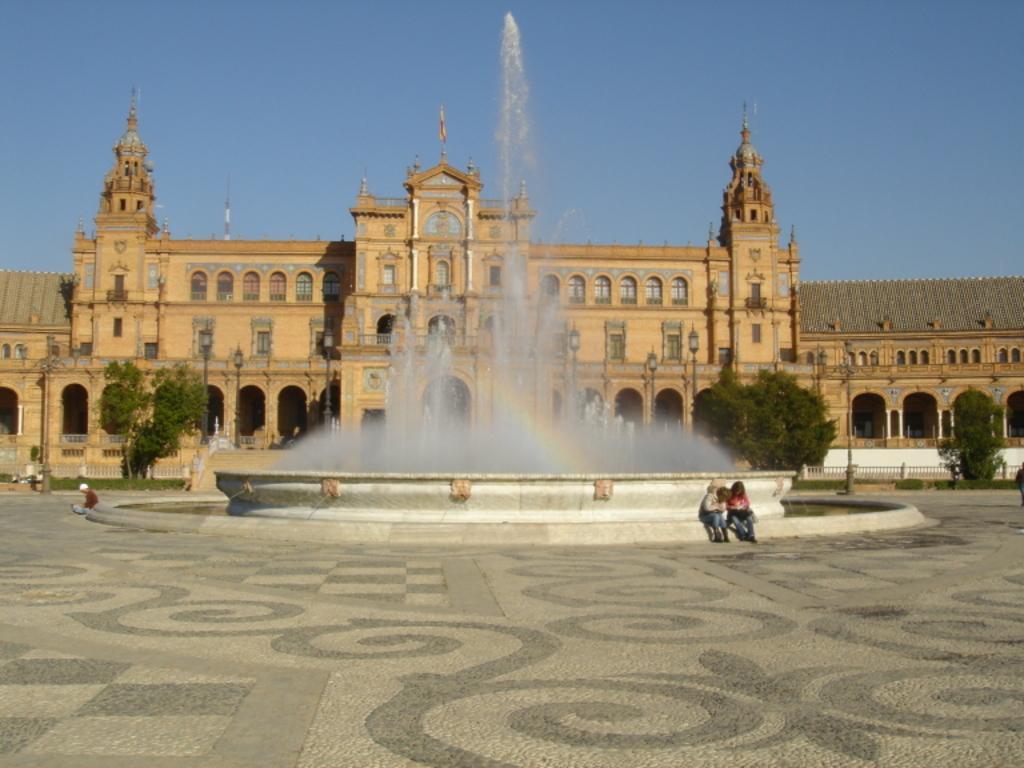Please provide a concise description of this image. In the foreground of the picture there is pavement. In the center of the picture there are people and fountain. In the background there are trees, railing and building. At the top of the building there is a flag. Sky is clear and it is sunny. 